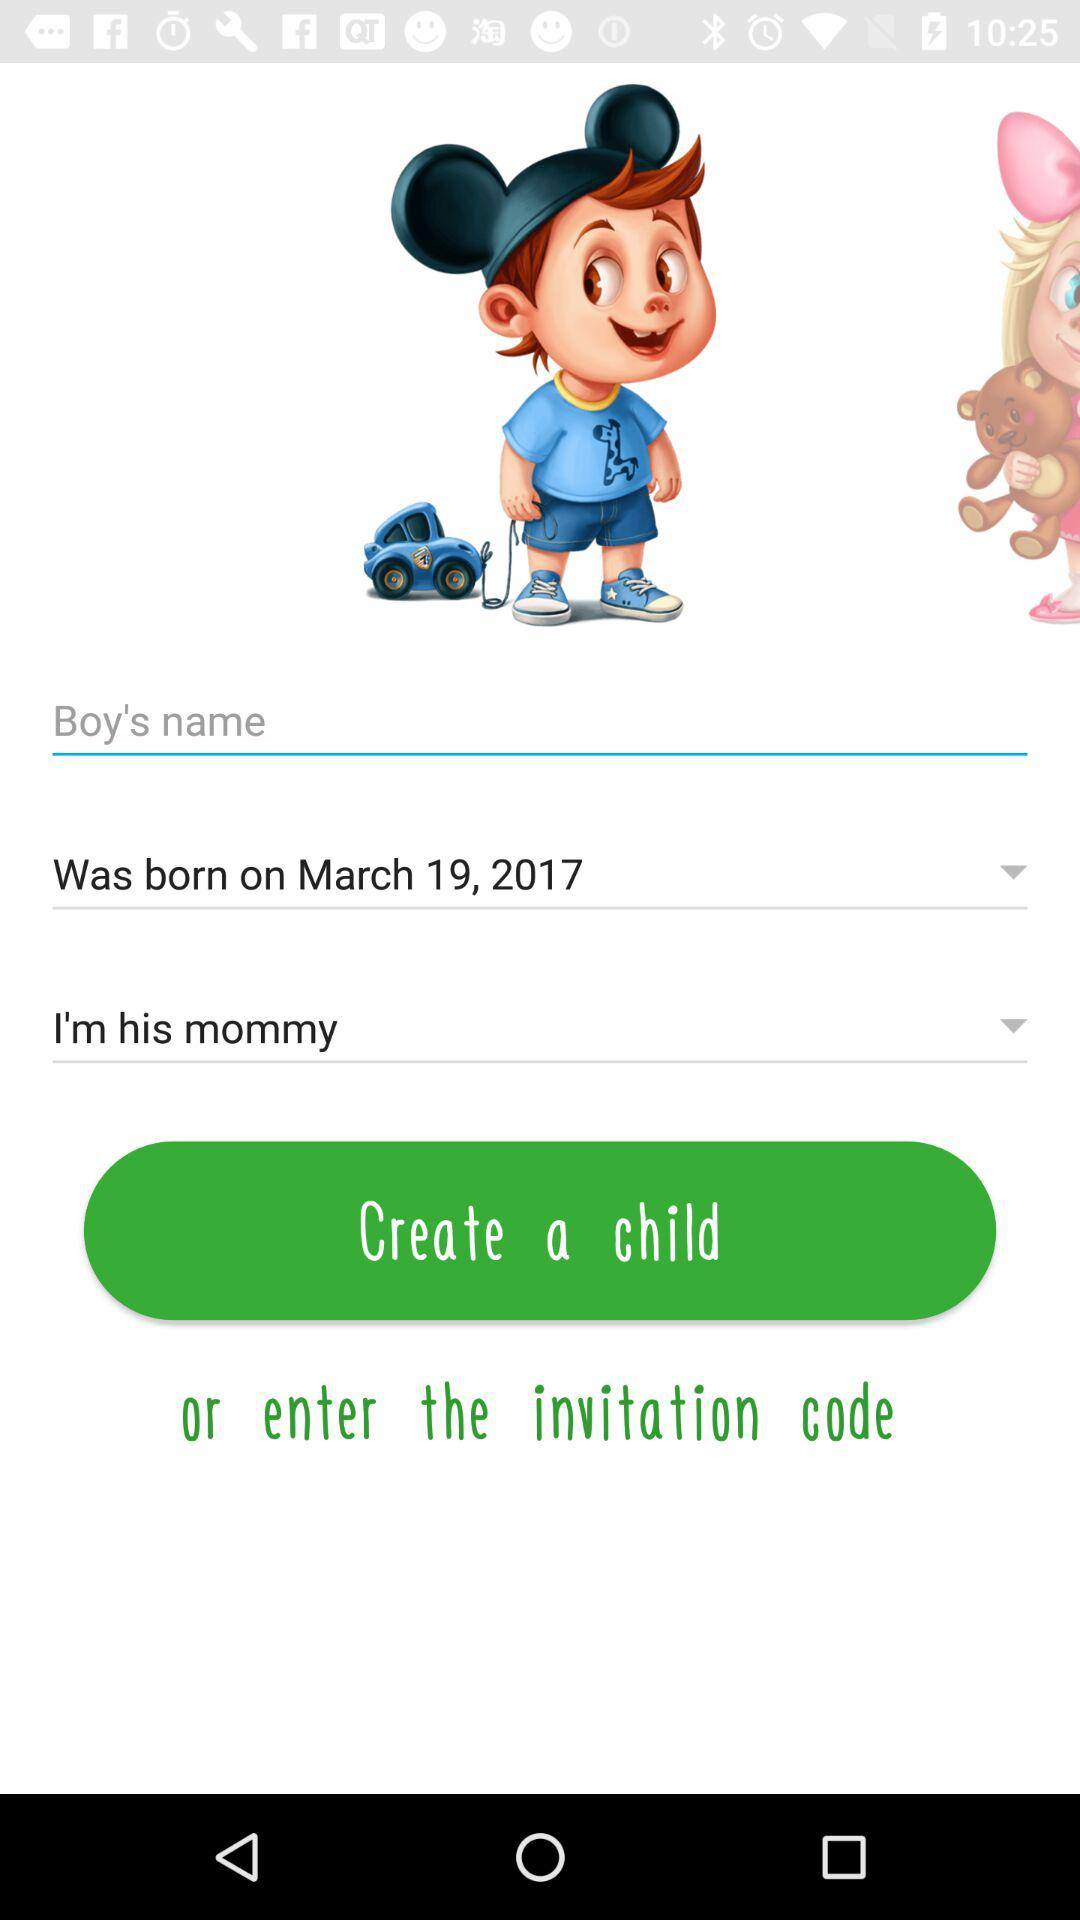What's the birth date? The birth date is March 19, 2017. 